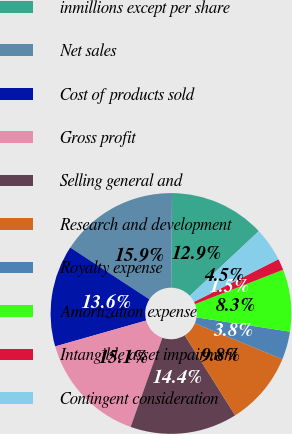Convert chart. <chart><loc_0><loc_0><loc_500><loc_500><pie_chart><fcel>inmillions except per share<fcel>Net sales<fcel>Cost of products sold<fcel>Gross profit<fcel>Selling general and<fcel>Research and development<fcel>Royalty expense<fcel>Amortization expense<fcel>Intangible asset impairment<fcel>Contingent consideration<nl><fcel>12.88%<fcel>15.91%<fcel>13.64%<fcel>15.15%<fcel>14.39%<fcel>9.85%<fcel>3.79%<fcel>8.33%<fcel>1.52%<fcel>4.55%<nl></chart> 